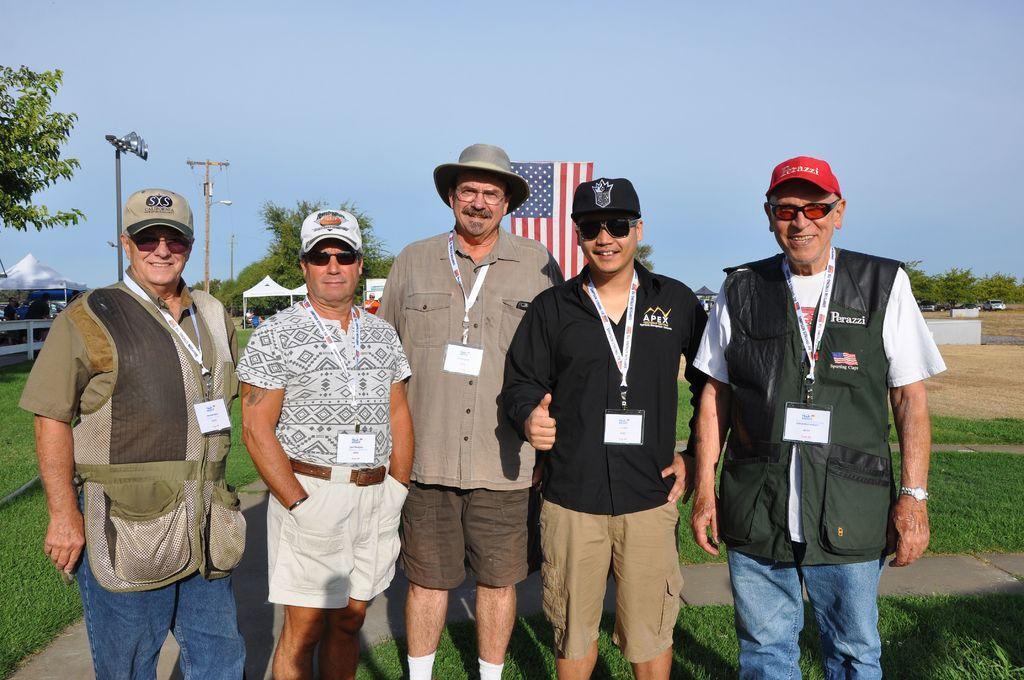Can you describe this image briefly? In this image I can see five people standing in the center and posing for the picture. I can see a garden behind them. I can see some shelters, light poles, electric poles, a flag hoarding, trees, some vehicles far behind them. At the top of the image I can see the sky. 